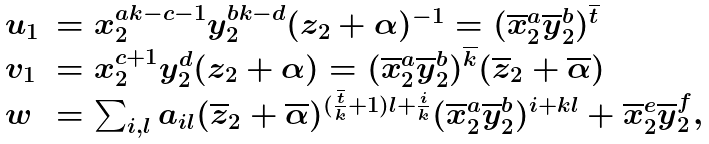Convert formula to latex. <formula><loc_0><loc_0><loc_500><loc_500>\begin{array} { l l } u _ { 1 } & = x _ { 2 } ^ { a k - c - 1 } y _ { 2 } ^ { b k - d } ( z _ { 2 } + \alpha ) ^ { - 1 } = ( \overline { x } _ { 2 } ^ { a } \overline { y } _ { 2 } ^ { b } ) ^ { \overline { t } } \\ v _ { 1 } & = x _ { 2 } ^ { c + 1 } y _ { 2 } ^ { d } ( z _ { 2 } + \alpha ) = ( \overline { x } _ { 2 } ^ { a } \overline { y } _ { 2 } ^ { b } ) ^ { \overline { k } } ( \overline { z } _ { 2 } + \overline { \alpha } ) \\ w & = \sum _ { i , l } a _ { i l } ( \overline { z } _ { 2 } + \overline { \alpha } ) ^ { ( \frac { \overline { t } } { k } + 1 ) l + \frac { i } { k } } ( \overline { x } _ { 2 } ^ { a } \overline { y } _ { 2 } ^ { b } ) ^ { i + k l } + \overline { x } _ { 2 } ^ { e } \overline { y } _ { 2 } ^ { f } , \end{array}</formula> 